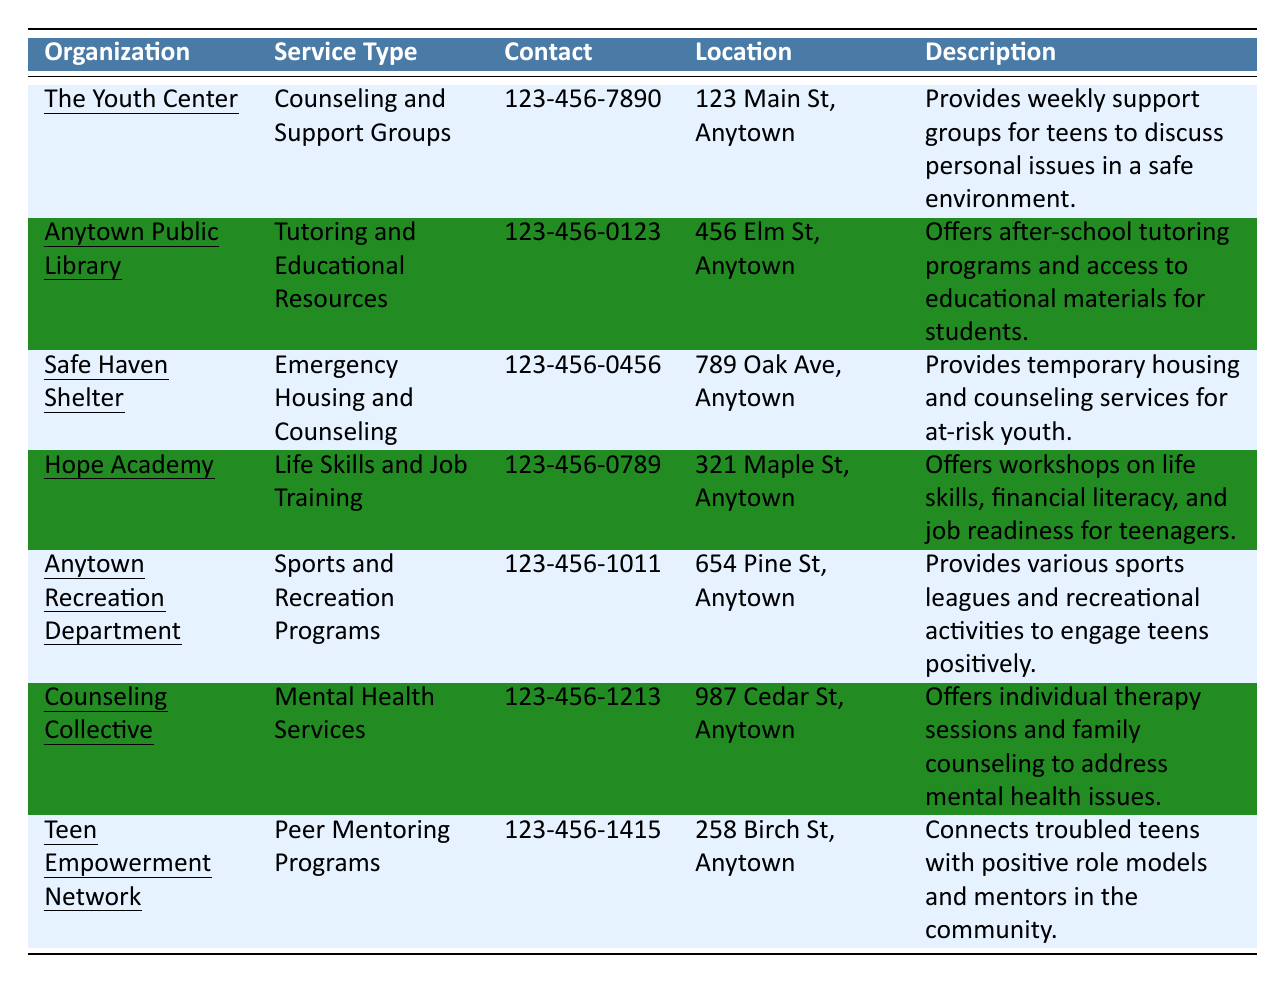What is the contact number for The Youth Center? The table shows that the contact number for The Youth Center is listed in the "Contact" column. It is 123-456-7890.
Answer: 123-456-7890 What type of services does Hope Academy provide? By looking at the "Service Type" column for Hope Academy, it is indicated that it offers "Life Skills and Job Training."
Answer: Life Skills and Job Training Does Safe Haven Shelter offer counseling services? The "Description" for Safe Haven Shelter mentions it provides counseling services along with emergency housing, confirming that it does.
Answer: Yes Which organization provides after-school tutoring programs? Anytown Public Library is mentioned in the "Service Type" column as providing "Tutoring and Educational Resources," which includes after-school tutoring programs.
Answer: Anytown Public Library What is the location of Counseling Collective? The location is provided in the "Location" column next to Counseling Collective, which states it is at 987 Cedar St, Anytown.
Answer: 987 Cedar St, Anytown What service types are offered by organizations that give housing support? Both Safe Haven Shelter offers "Emergency Housing and Counseling," and The Youth Center provides "Counseling and Support Groups."
Answer: Emergency Housing and Counseling; Counseling and Support Groups Are there more organizations providing support for mental health or sports programs? By counting, Counseling Collective offers mental health services, whereas Anytown Recreation Department offers sports programs. Both categories have 1 organization each, showing they are equal.
Answer: Equal What organization has the longest description mentioned in the table? By comparing the lengths of descriptions, Hope Academy's description regarding its workshops is the longest as it contains details about multiple aspects of its services.
Answer: Hope Academy How many organizations provide peer mentoring or supportive group activities? Teen Empowerment Network provides "Peer Mentoring Programs," and The Youth Center provides "Counseling and Support Groups," totaling 2 organizations that offer such activities.
Answer: 2 Which organization is closest to the Anytown Recreation Department? The location of Anytown Recreation Department is 654 Pine St, and the nearest organization by analyzing locations is The Youth Center at 123 Main St, as both are within the same vicinity.
Answer: The Youth Center 